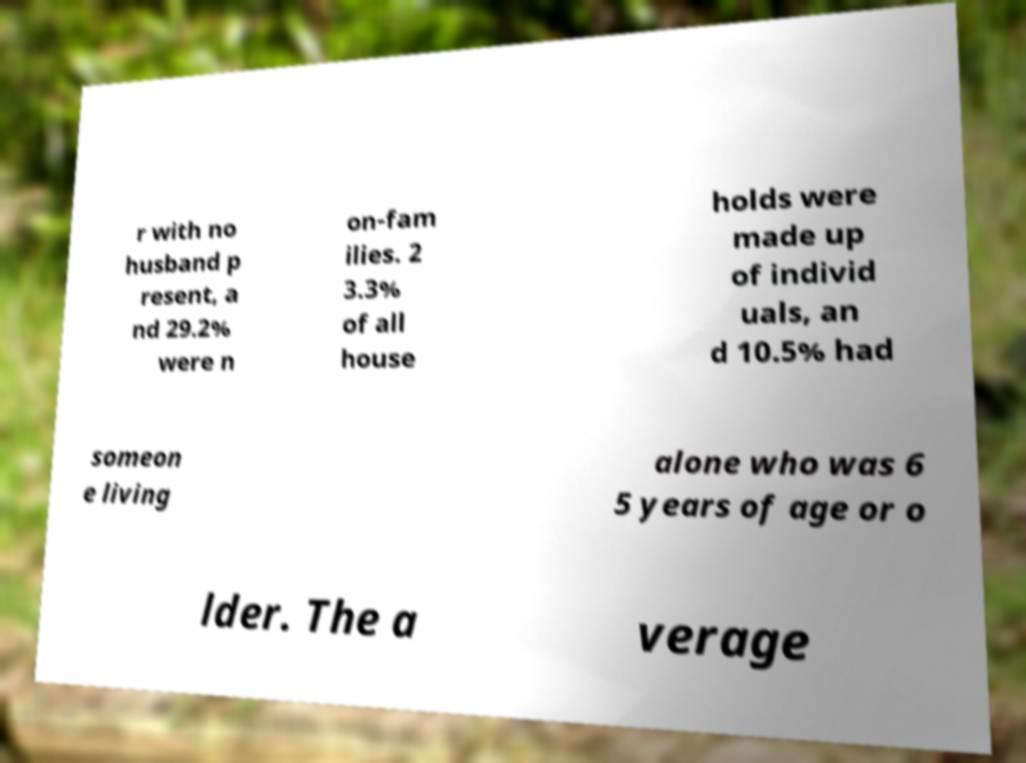Could you assist in decoding the text presented in this image and type it out clearly? r with no husband p resent, a nd 29.2% were n on-fam ilies. 2 3.3% of all house holds were made up of individ uals, an d 10.5% had someon e living alone who was 6 5 years of age or o lder. The a verage 